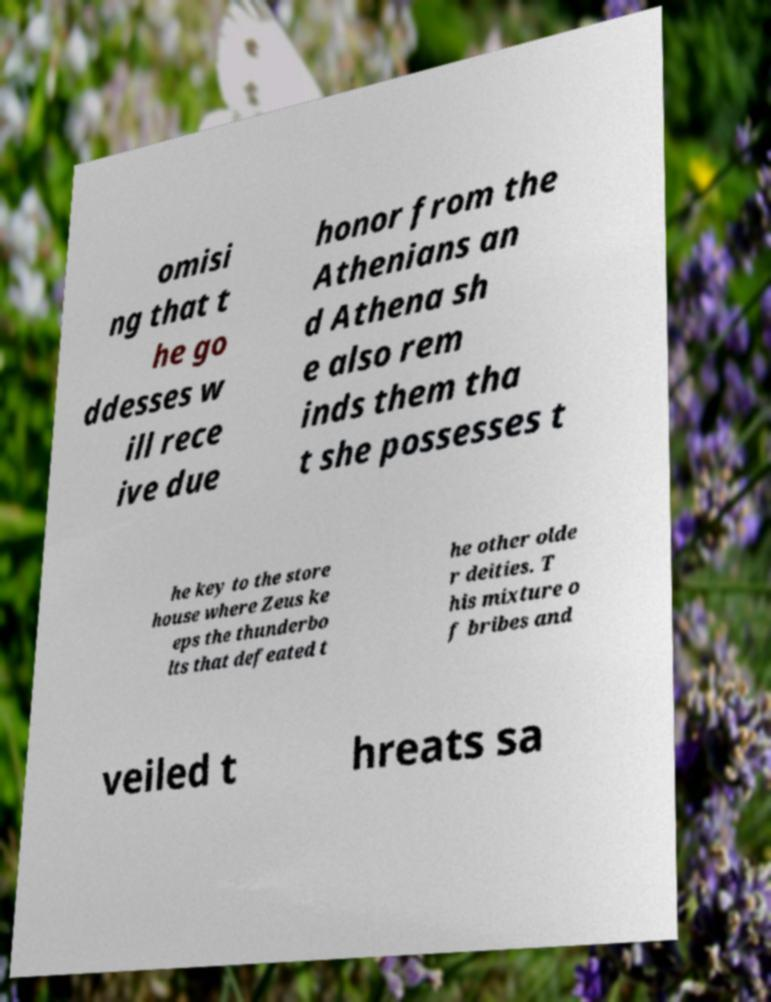There's text embedded in this image that I need extracted. Can you transcribe it verbatim? omisi ng that t he go ddesses w ill rece ive due honor from the Athenians an d Athena sh e also rem inds them tha t she possesses t he key to the store house where Zeus ke eps the thunderbo lts that defeated t he other olde r deities. T his mixture o f bribes and veiled t hreats sa 